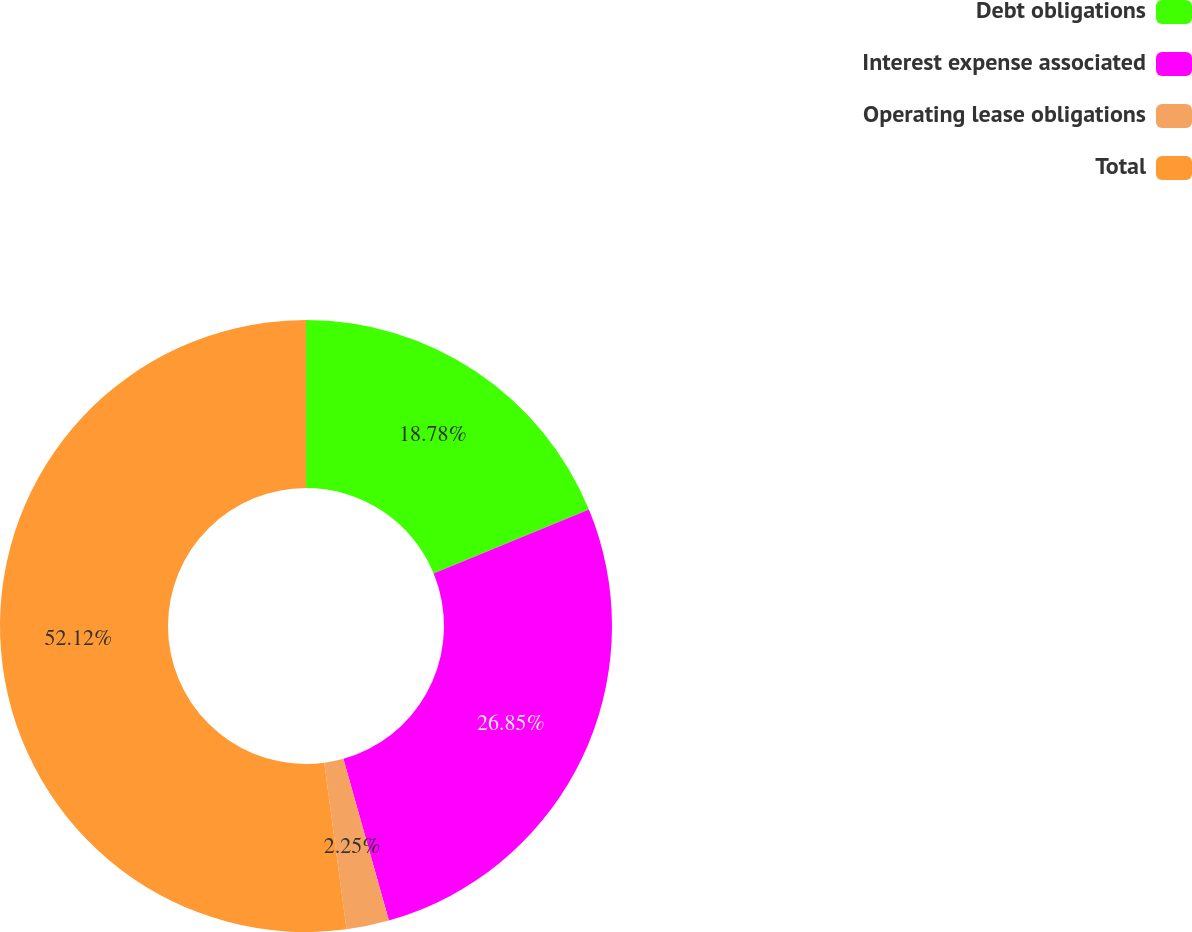<chart> <loc_0><loc_0><loc_500><loc_500><pie_chart><fcel>Debt obligations<fcel>Interest expense associated<fcel>Operating lease obligations<fcel>Total<nl><fcel>18.78%<fcel>26.85%<fcel>2.25%<fcel>52.11%<nl></chart> 